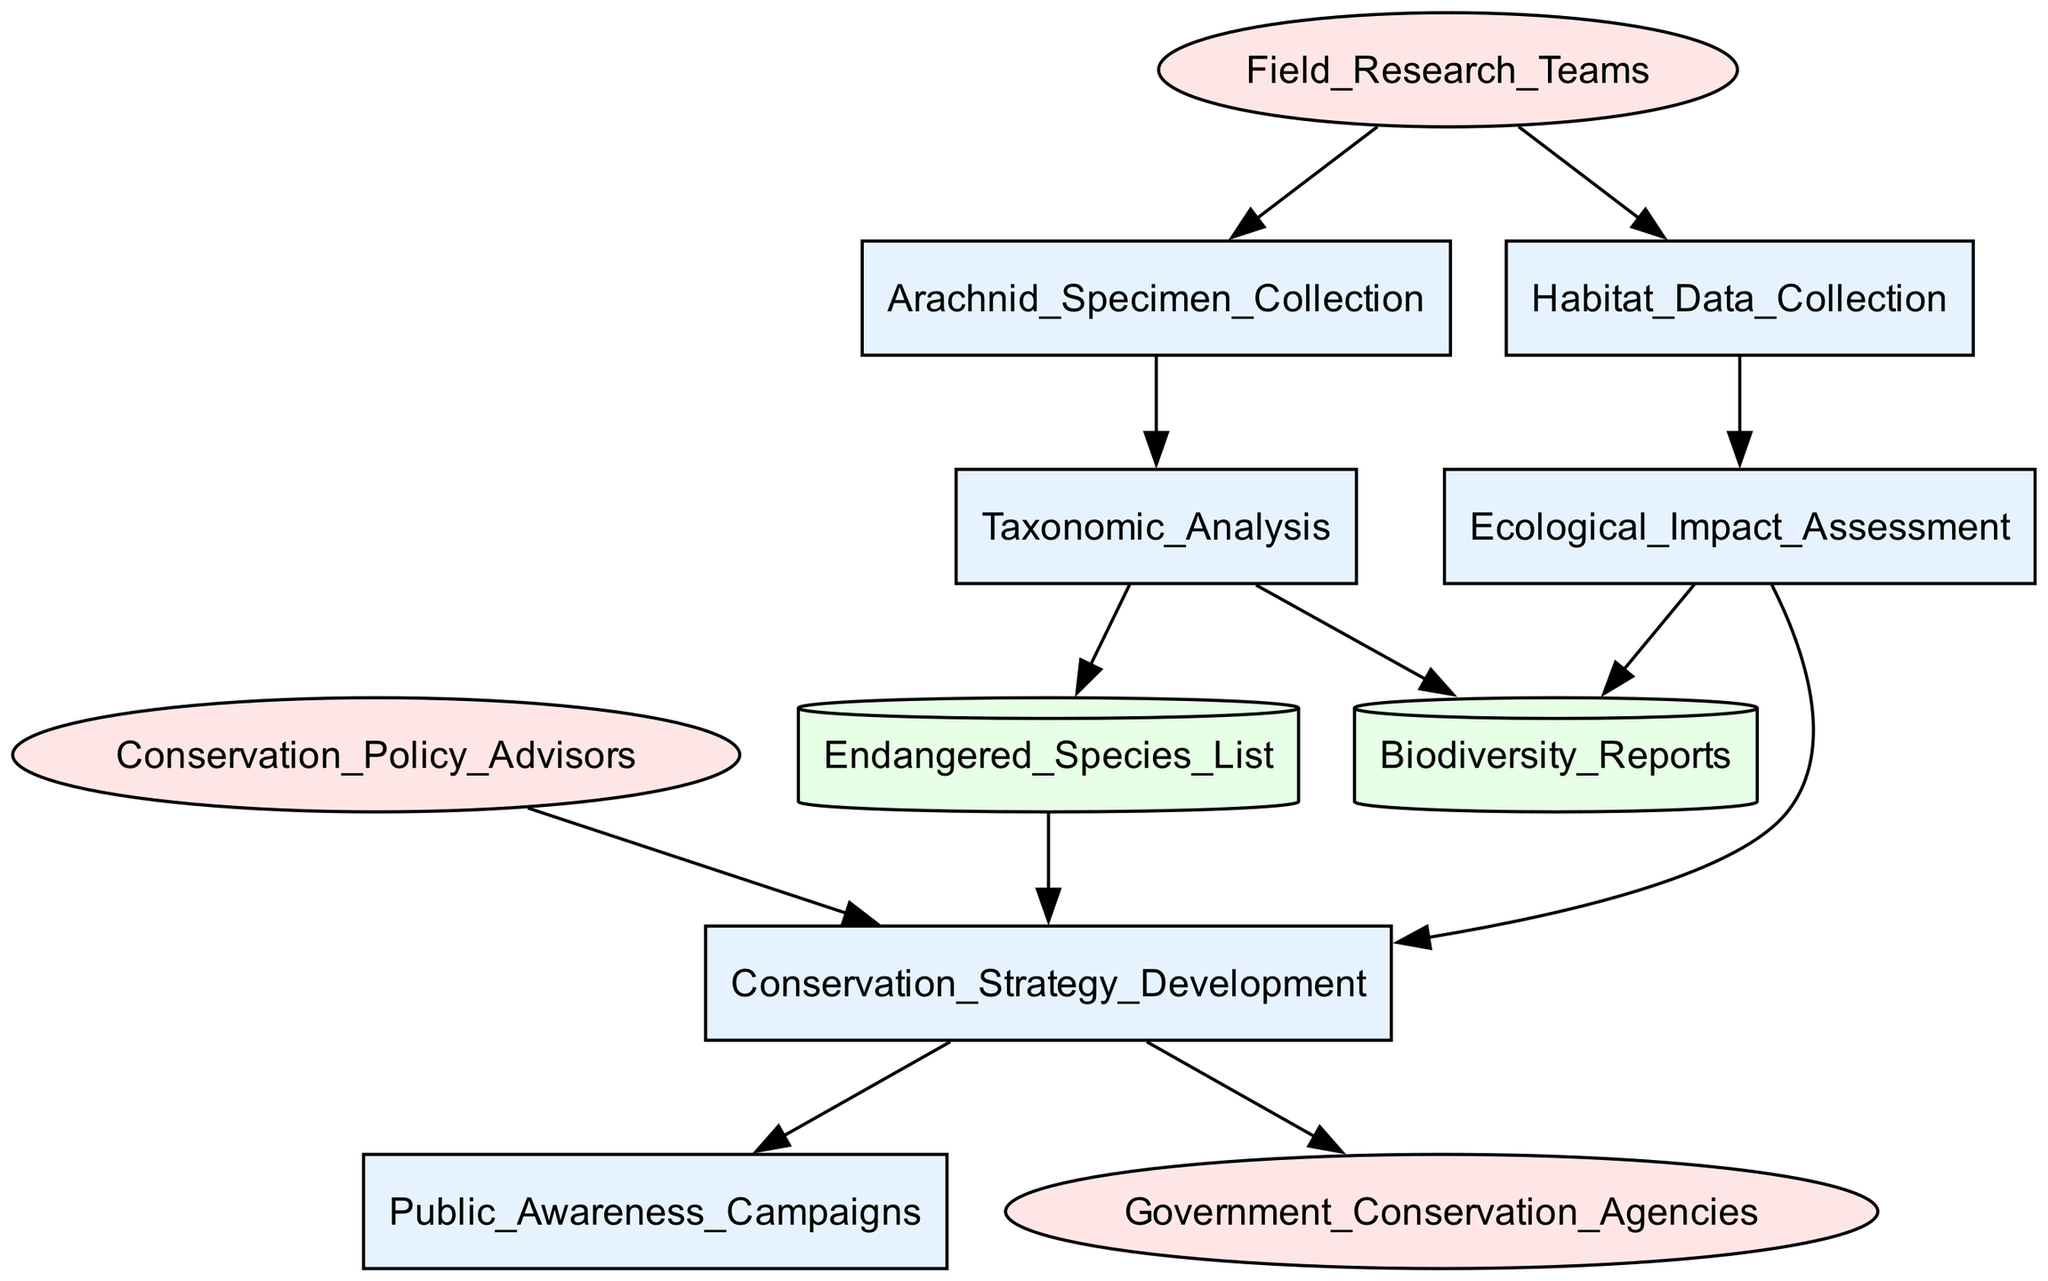What is the first process in the workflow? The first process in the workflow is represented by the node 'Arachnid_Specimen_Collection', which collects arachnid specimens.
Answer: Arachnid_Specimen_Collection How many external entities are represented in the diagram? There are three external entities in the diagram: 'Field_Research_Teams', 'Conservation_Policy_Advisors', and 'Government_Conservation_Agencies'.
Answer: 3 Which process follows the 'Taxonomic_Analysis'? The process that follows 'Taxonomic_Analysis' is 'Endangered_Species_List', where taxonomic results are stored for species identification and risk assessment.
Answer: Endangered_Species_List What is the relationship between 'Ecological_Impact_Assessment' and 'Conservation_Strategy_Development'? 'Ecological_Impact_Assessment' feeds into 'Conservation_Strategy_Development', indicating that the evaluation of environmental impact influences the formulation of strategies to protect endangered arachnids.
Answer: influences Which data store is updated by both 'Taxonomic_Analysis' and 'Ecological_Impact_Assessment'? The data store that is updated by both 'Taxonomic_Analysis' and 'Ecological_Impact_Assessment' is 'Biodiversity_Reports', which documents species richness and population status.
Answer: Biodiversity_Reports What role do 'Conservation_Policy_Advisors' play in the workflow? 'Conservation_Policy_Advisors' provide input on conservation strategies and legal frameworks, influencing the development of conservation strategies.
Answer: provide input Which process is the final output of the workflow? The final output of the workflow, indicated by the flow from 'Conservation_Strategy_Development', is 'Public_Awareness_Campaigns', aiming to raise awareness about arachnid conservation.
Answer: Public_Awareness_Campaigns What connects 'Field_Research_Teams' to both main processes in the workflow? 'Field_Research_Teams' connects to 'Arachnid_Specimen_Collection' and 'Habitat_Data_Collection', indicating their role in initiating specimen collection and habitat monitoring.
Answer: two processes How many processes are in the workflow? The diagram contains eight processes, which include collecting specimens, analyzing taxonomy, assessing impact, developing strategies, and conducting awareness campaigns.
Answer: 8 What type of diagram is this? This is a Data Flow Diagram, depicted to illustrate the workflow involved in conservation decision-making for endangered arachnid species.
Answer: Data Flow Diagram 